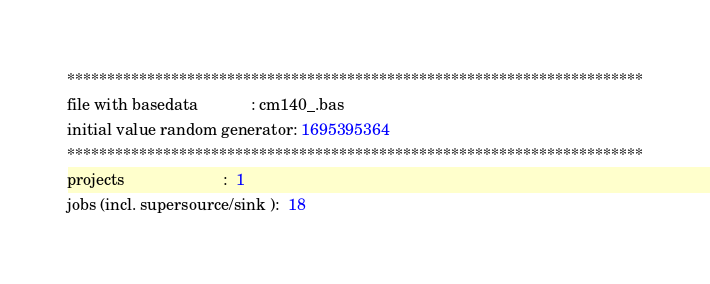<code> <loc_0><loc_0><loc_500><loc_500><_ObjectiveC_>************************************************************************
file with basedata            : cm140_.bas
initial value random generator: 1695395364
************************************************************************
projects                      :  1
jobs (incl. supersource/sink ):  18</code> 